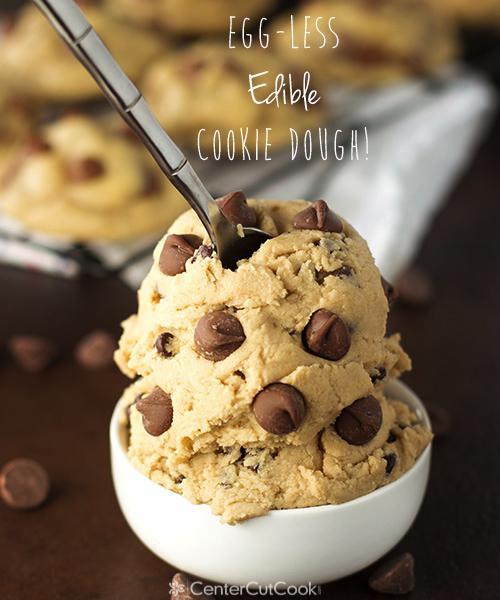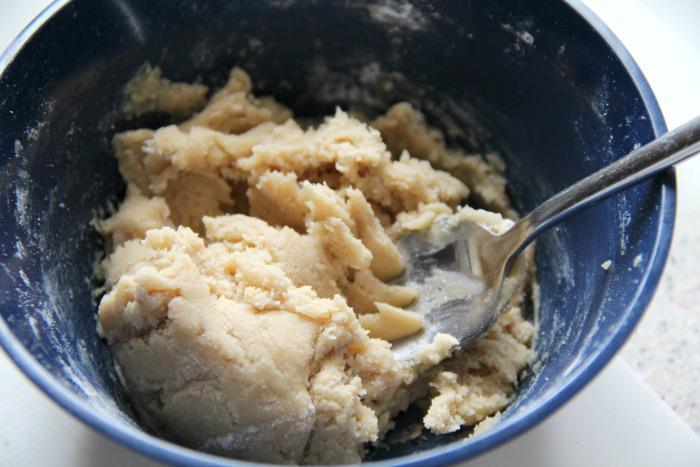The first image is the image on the left, the second image is the image on the right. For the images displayed, is the sentence "There is a single glass bowl holding chocolate chip cookie dough." factually correct? Answer yes or no. No. The first image is the image on the left, the second image is the image on the right. Evaluate the accuracy of this statement regarding the images: "A spoon is laying on the table.". Is it true? Answer yes or no. No. 